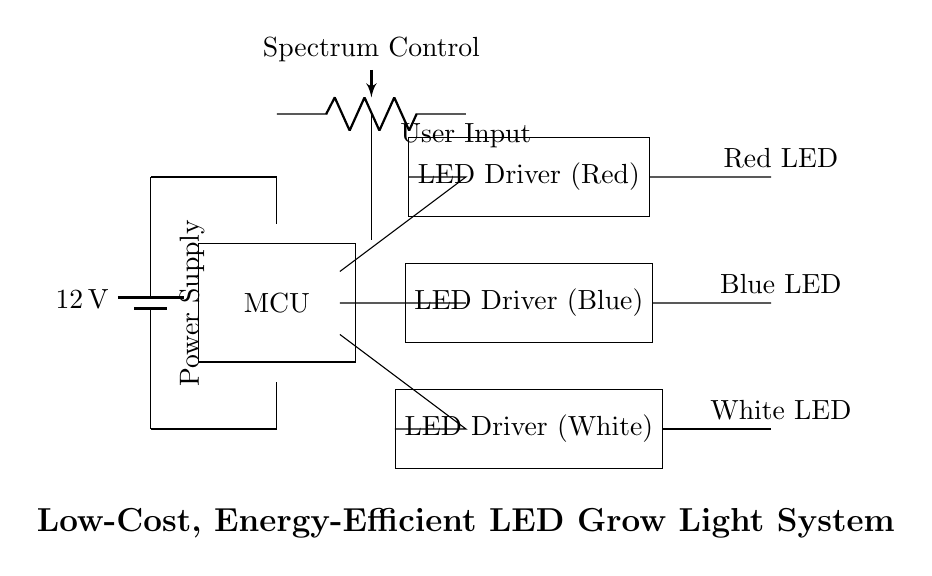What voltage does the power supply provide? The circuit indicates a battery with a label showing it provides 12 volts, which is the voltage for the entire system.
Answer: 12 volts What type of main components are used in this circuit? The components include a microcontroller, three LED drivers, three types of LEDs (red, blue, and white), and a spectrum control potentiometer.
Answer: Microcontroller, LED drivers, LEDs How many LED drivers are in the circuit? There are three LED drivers indicated in the diagram, each connected to a different type of LED.
Answer: Three What is the purpose of the potentiometer in this circuit? The potentiometer is labeled as "Spectrum Control" and is employed to adjust the intensity or output of the different LED spectrums.
Answer: Adjust spectrum What is the configuration of the LEDs in the circuit? The LEDs are in parallel configuration, each powered separately by their respective LED drivers, allowing simultaneous operation.
Answer: Parallel configuration How are the LED drivers connected to their respective LEDs? Each LED driver is directly connected to an LED, implying they supply power and control independently to each specified color LED.
Answer: Directly connected What types of LEDs are used in this grow light system? The circuit uses red, blue, and white LEDs, which are essential for plant growth as each color serves different purposes in photosynthesis.
Answer: Red, blue, white 